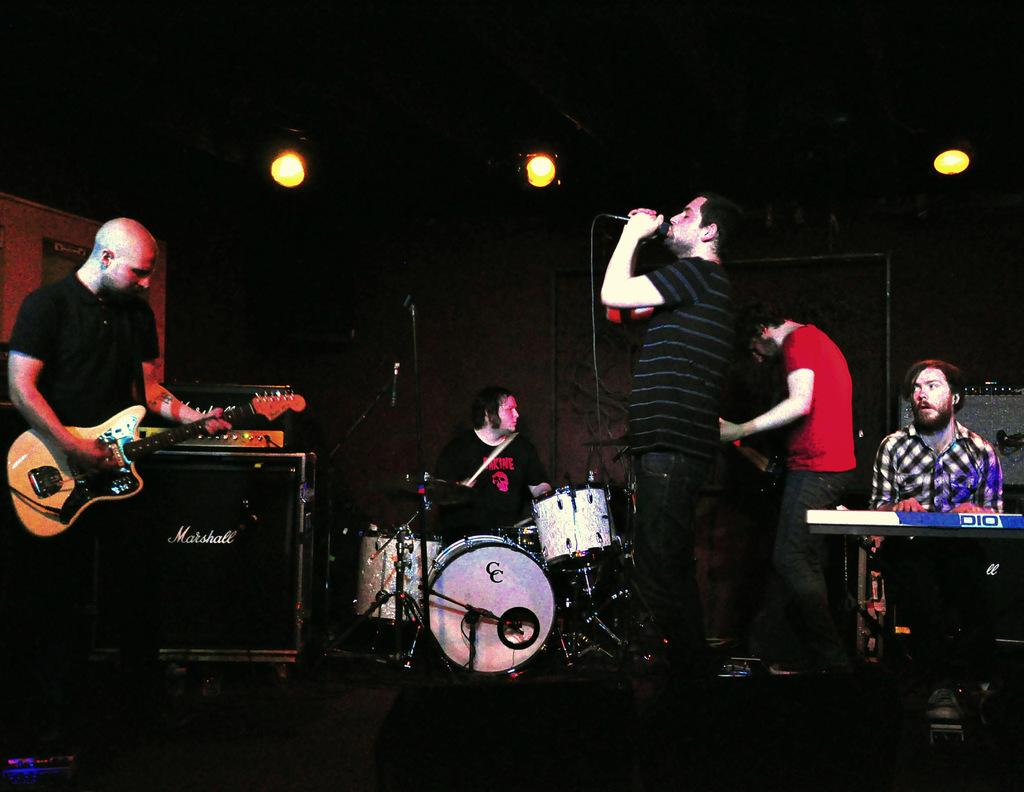How many people are in the image? There is a group of people in the image. What are the people in the image doing? The people are playing musical instruments. What is the average income of the sheep in the park in the image? There are no sheep or parks present in the image; it features a group of people playing musical instruments. 